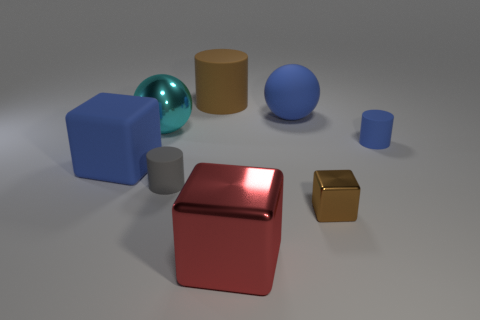Are there any gray cylinders that have the same size as the brown cylinder?
Ensure brevity in your answer.  No. How many things are either objects that are in front of the gray rubber cylinder or objects that are to the left of the large blue rubber sphere?
Offer a very short reply. 6. The large thing that is right of the shiny block that is left of the small shiny object is what color?
Provide a succinct answer. Blue. There is another big cylinder that is the same material as the gray cylinder; what is its color?
Ensure brevity in your answer.  Brown. What number of large things are the same color as the tiny shiny cube?
Your answer should be very brief. 1. What number of objects are small metal objects or large red shiny things?
Offer a terse response. 2. The blue object that is the same size as the brown shiny object is what shape?
Offer a very short reply. Cylinder. What number of large things are both behind the red block and right of the brown rubber object?
Provide a short and direct response. 1. What is the material of the brown object that is behind the large cyan sphere?
Ensure brevity in your answer.  Rubber. What size is the red block that is made of the same material as the big cyan sphere?
Keep it short and to the point. Large. 